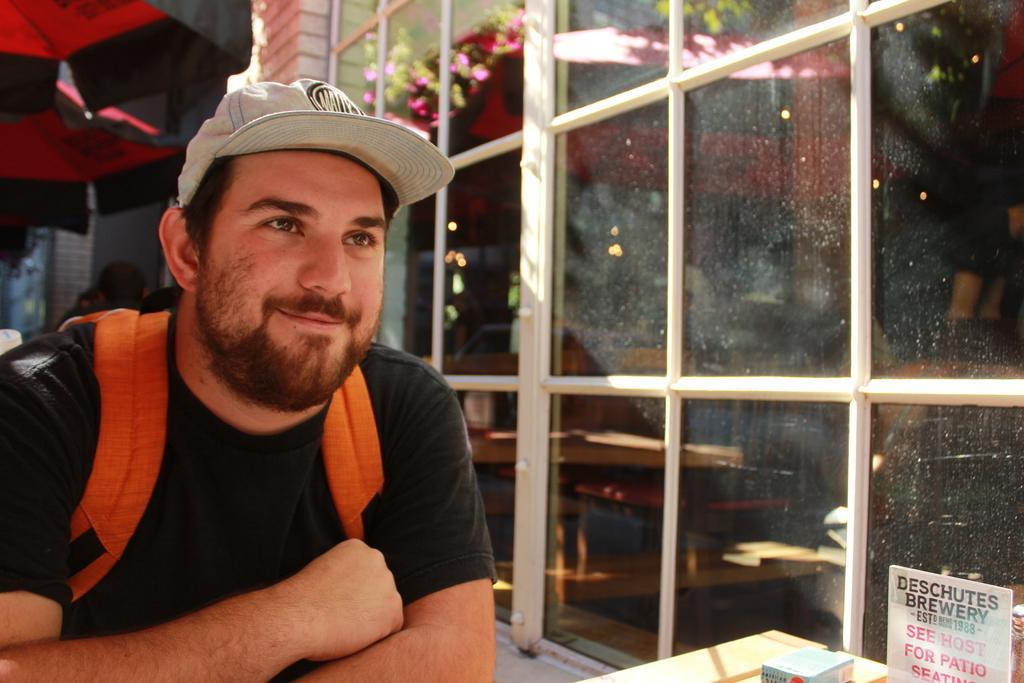How would you summarize this image in a sentence or two? In the foreground of this image, there is a man in black T shirt and wearing backpack and having smile on his face. On the right side of this image, there is a glass window and cards. In the background, there is an umbrella, wall and plants. 